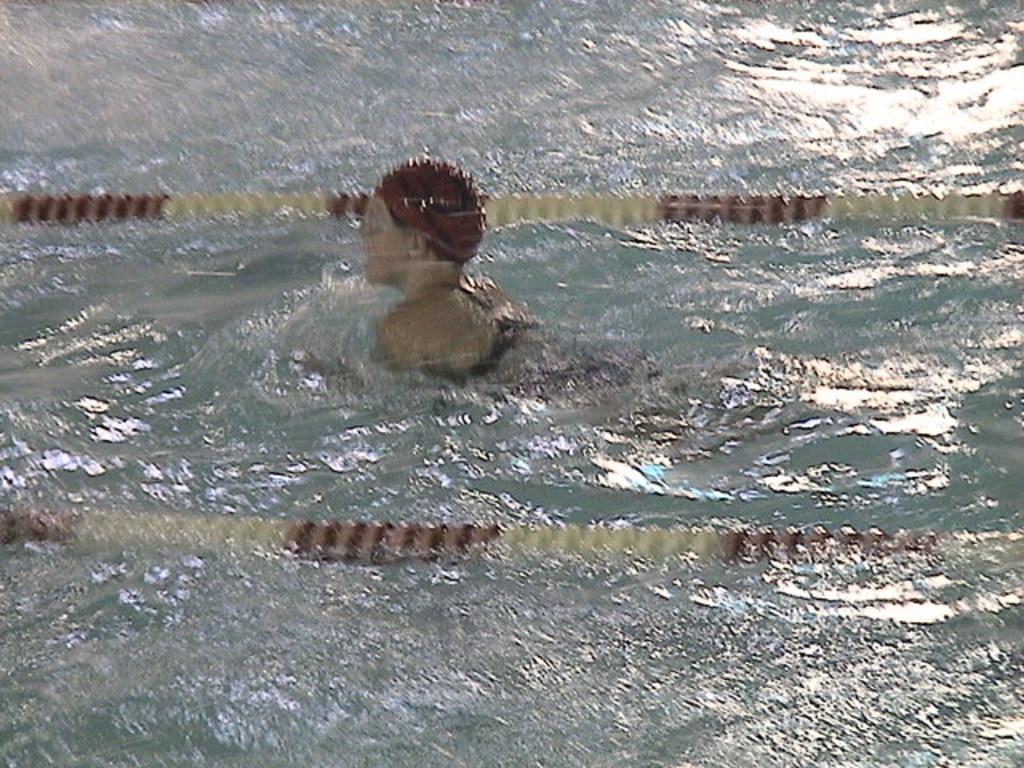Can you describe this image briefly? In this picture, we see the woman is swimming in the water. This water might be in the swimming pool. On either side of her, we see the ropes in white and brown color. 